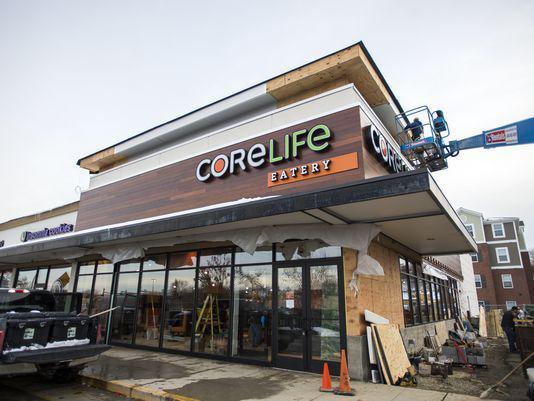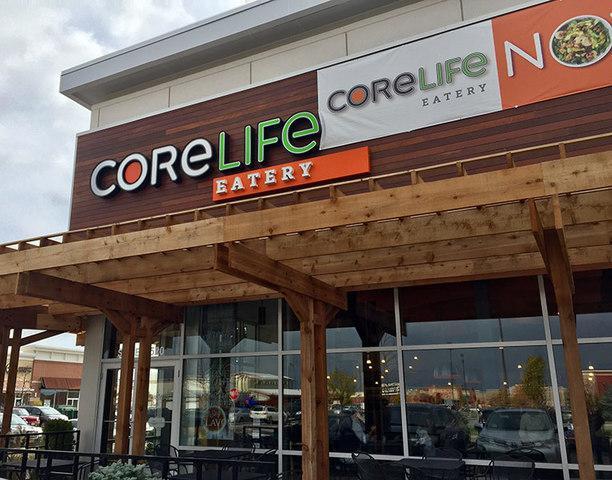The first image is the image on the left, the second image is the image on the right. Assess this claim about the two images: "A white and orange banner is hanging on the front of a restaurant.". Correct or not? Answer yes or no. Yes. The first image is the image on the left, the second image is the image on the right. Examine the images to the left and right. Is the description "Two restaurants are displaying a permanent sign with the name Core Life Eatery." accurate? Answer yes or no. Yes. 